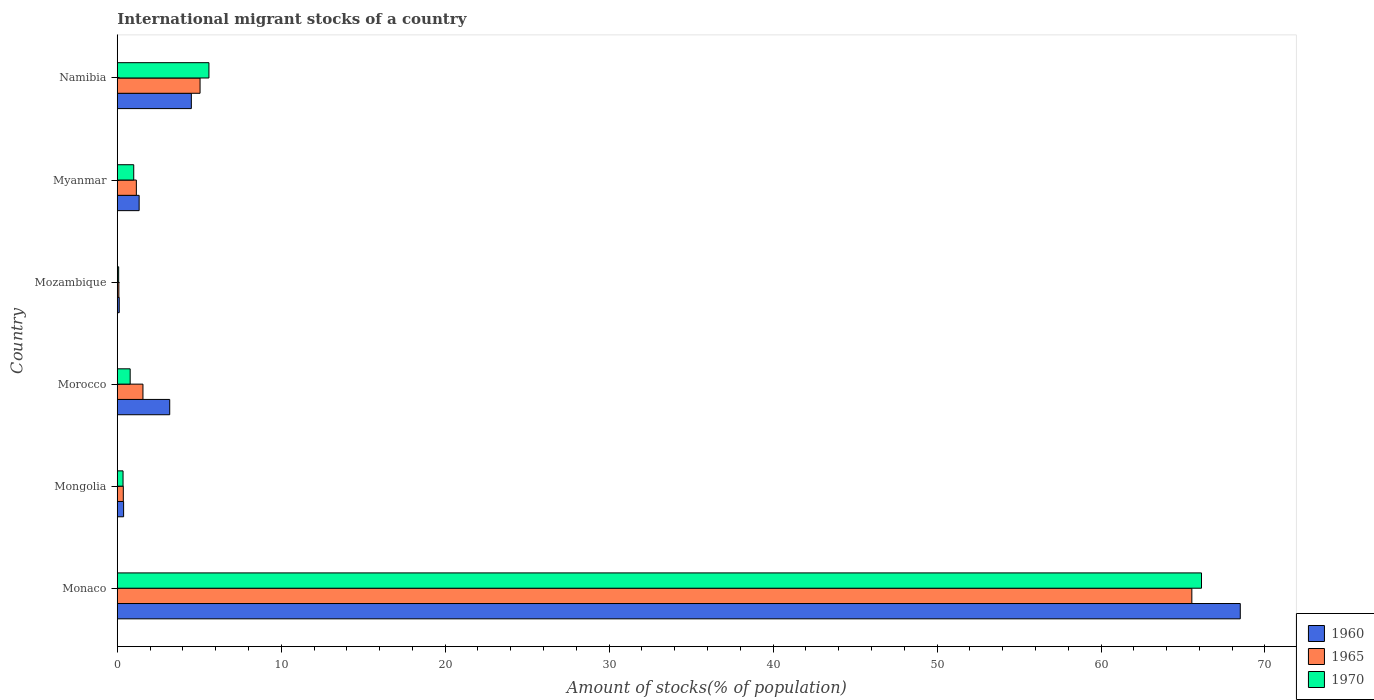How many different coloured bars are there?
Your response must be concise. 3. How many groups of bars are there?
Your answer should be compact. 6. Are the number of bars per tick equal to the number of legend labels?
Offer a terse response. Yes. What is the label of the 3rd group of bars from the top?
Provide a succinct answer. Mozambique. In how many cases, is the number of bars for a given country not equal to the number of legend labels?
Your response must be concise. 0. What is the amount of stocks in in 1960 in Namibia?
Ensure brevity in your answer.  4.52. Across all countries, what is the maximum amount of stocks in in 1960?
Give a very brief answer. 68.5. Across all countries, what is the minimum amount of stocks in in 1960?
Ensure brevity in your answer.  0.12. In which country was the amount of stocks in in 1970 maximum?
Ensure brevity in your answer.  Monaco. In which country was the amount of stocks in in 1965 minimum?
Offer a very short reply. Mozambique. What is the total amount of stocks in in 1960 in the graph?
Make the answer very short. 78.05. What is the difference between the amount of stocks in in 1970 in Mongolia and that in Namibia?
Keep it short and to the point. -5.24. What is the difference between the amount of stocks in in 1965 in Namibia and the amount of stocks in in 1970 in Mozambique?
Keep it short and to the point. 4.96. What is the average amount of stocks in in 1960 per country?
Offer a very short reply. 13.01. What is the difference between the amount of stocks in in 1970 and amount of stocks in in 1960 in Mozambique?
Your response must be concise. -0.04. What is the ratio of the amount of stocks in in 1965 in Mongolia to that in Myanmar?
Your answer should be very brief. 0.32. Is the amount of stocks in in 1960 in Mozambique less than that in Namibia?
Your answer should be very brief. Yes. Is the difference between the amount of stocks in in 1970 in Morocco and Namibia greater than the difference between the amount of stocks in in 1960 in Morocco and Namibia?
Make the answer very short. No. What is the difference between the highest and the second highest amount of stocks in in 1960?
Make the answer very short. 63.98. What is the difference between the highest and the lowest amount of stocks in in 1965?
Your answer should be very brief. 65.44. What does the 2nd bar from the top in Mongolia represents?
Provide a succinct answer. 1965. How many bars are there?
Provide a short and direct response. 18. What is the difference between two consecutive major ticks on the X-axis?
Make the answer very short. 10. Does the graph contain any zero values?
Make the answer very short. No. Does the graph contain grids?
Your response must be concise. No. Where does the legend appear in the graph?
Provide a short and direct response. Bottom right. How are the legend labels stacked?
Offer a very short reply. Vertical. What is the title of the graph?
Give a very brief answer. International migrant stocks of a country. Does "2012" appear as one of the legend labels in the graph?
Keep it short and to the point. No. What is the label or title of the X-axis?
Give a very brief answer. Amount of stocks(% of population). What is the label or title of the Y-axis?
Provide a short and direct response. Country. What is the Amount of stocks(% of population) of 1960 in Monaco?
Offer a very short reply. 68.5. What is the Amount of stocks(% of population) of 1965 in Monaco?
Provide a short and direct response. 65.54. What is the Amount of stocks(% of population) in 1970 in Monaco?
Offer a very short reply. 66.13. What is the Amount of stocks(% of population) of 1960 in Mongolia?
Offer a terse response. 0.39. What is the Amount of stocks(% of population) of 1965 in Mongolia?
Your answer should be compact. 0.37. What is the Amount of stocks(% of population) in 1970 in Mongolia?
Offer a very short reply. 0.35. What is the Amount of stocks(% of population) in 1960 in Morocco?
Ensure brevity in your answer.  3.2. What is the Amount of stocks(% of population) of 1965 in Morocco?
Offer a terse response. 1.57. What is the Amount of stocks(% of population) in 1970 in Morocco?
Keep it short and to the point. 0.79. What is the Amount of stocks(% of population) of 1960 in Mozambique?
Keep it short and to the point. 0.12. What is the Amount of stocks(% of population) of 1965 in Mozambique?
Offer a terse response. 0.1. What is the Amount of stocks(% of population) of 1970 in Mozambique?
Provide a short and direct response. 0.08. What is the Amount of stocks(% of population) of 1960 in Myanmar?
Offer a terse response. 1.33. What is the Amount of stocks(% of population) of 1965 in Myanmar?
Your response must be concise. 1.16. What is the Amount of stocks(% of population) of 1970 in Myanmar?
Keep it short and to the point. 1. What is the Amount of stocks(% of population) in 1960 in Namibia?
Keep it short and to the point. 4.52. What is the Amount of stocks(% of population) of 1965 in Namibia?
Your answer should be very brief. 5.05. What is the Amount of stocks(% of population) of 1970 in Namibia?
Your response must be concise. 5.59. Across all countries, what is the maximum Amount of stocks(% of population) of 1960?
Give a very brief answer. 68.5. Across all countries, what is the maximum Amount of stocks(% of population) in 1965?
Give a very brief answer. 65.54. Across all countries, what is the maximum Amount of stocks(% of population) in 1970?
Provide a short and direct response. 66.13. Across all countries, what is the minimum Amount of stocks(% of population) in 1960?
Your answer should be compact. 0.12. Across all countries, what is the minimum Amount of stocks(% of population) of 1965?
Give a very brief answer. 0.1. Across all countries, what is the minimum Amount of stocks(% of population) in 1970?
Offer a terse response. 0.08. What is the total Amount of stocks(% of population) in 1960 in the graph?
Offer a terse response. 78.05. What is the total Amount of stocks(% of population) in 1965 in the graph?
Provide a succinct answer. 73.78. What is the total Amount of stocks(% of population) in 1970 in the graph?
Provide a short and direct response. 73.95. What is the difference between the Amount of stocks(% of population) in 1960 in Monaco and that in Mongolia?
Keep it short and to the point. 68.11. What is the difference between the Amount of stocks(% of population) of 1965 in Monaco and that in Mongolia?
Provide a short and direct response. 65.17. What is the difference between the Amount of stocks(% of population) in 1970 in Monaco and that in Mongolia?
Keep it short and to the point. 65.78. What is the difference between the Amount of stocks(% of population) of 1960 in Monaco and that in Morocco?
Provide a succinct answer. 65.3. What is the difference between the Amount of stocks(% of population) in 1965 in Monaco and that in Morocco?
Ensure brevity in your answer.  63.98. What is the difference between the Amount of stocks(% of population) of 1970 in Monaco and that in Morocco?
Provide a succinct answer. 65.34. What is the difference between the Amount of stocks(% of population) of 1960 in Monaco and that in Mozambique?
Provide a succinct answer. 68.38. What is the difference between the Amount of stocks(% of population) in 1965 in Monaco and that in Mozambique?
Give a very brief answer. 65.44. What is the difference between the Amount of stocks(% of population) of 1970 in Monaco and that in Mozambique?
Provide a short and direct response. 66.05. What is the difference between the Amount of stocks(% of population) of 1960 in Monaco and that in Myanmar?
Offer a terse response. 67.16. What is the difference between the Amount of stocks(% of population) of 1965 in Monaco and that in Myanmar?
Keep it short and to the point. 64.38. What is the difference between the Amount of stocks(% of population) in 1970 in Monaco and that in Myanmar?
Your response must be concise. 65.13. What is the difference between the Amount of stocks(% of population) of 1960 in Monaco and that in Namibia?
Your answer should be compact. 63.98. What is the difference between the Amount of stocks(% of population) of 1965 in Monaco and that in Namibia?
Give a very brief answer. 60.49. What is the difference between the Amount of stocks(% of population) in 1970 in Monaco and that in Namibia?
Provide a short and direct response. 60.54. What is the difference between the Amount of stocks(% of population) of 1960 in Mongolia and that in Morocco?
Your answer should be very brief. -2.81. What is the difference between the Amount of stocks(% of population) of 1965 in Mongolia and that in Morocco?
Your answer should be compact. -1.2. What is the difference between the Amount of stocks(% of population) in 1970 in Mongolia and that in Morocco?
Your answer should be compact. -0.43. What is the difference between the Amount of stocks(% of population) of 1960 in Mongolia and that in Mozambique?
Your answer should be compact. 0.27. What is the difference between the Amount of stocks(% of population) in 1965 in Mongolia and that in Mozambique?
Your answer should be very brief. 0.27. What is the difference between the Amount of stocks(% of population) of 1970 in Mongolia and that in Mozambique?
Provide a short and direct response. 0.27. What is the difference between the Amount of stocks(% of population) of 1960 in Mongolia and that in Myanmar?
Make the answer very short. -0.95. What is the difference between the Amount of stocks(% of population) in 1965 in Mongolia and that in Myanmar?
Provide a succinct answer. -0.8. What is the difference between the Amount of stocks(% of population) in 1970 in Mongolia and that in Myanmar?
Ensure brevity in your answer.  -0.65. What is the difference between the Amount of stocks(% of population) in 1960 in Mongolia and that in Namibia?
Give a very brief answer. -4.13. What is the difference between the Amount of stocks(% of population) of 1965 in Mongolia and that in Namibia?
Provide a short and direct response. -4.68. What is the difference between the Amount of stocks(% of population) in 1970 in Mongolia and that in Namibia?
Offer a terse response. -5.24. What is the difference between the Amount of stocks(% of population) in 1960 in Morocco and that in Mozambique?
Make the answer very short. 3.08. What is the difference between the Amount of stocks(% of population) of 1965 in Morocco and that in Mozambique?
Offer a very short reply. 1.47. What is the difference between the Amount of stocks(% of population) in 1970 in Morocco and that in Mozambique?
Make the answer very short. 0.7. What is the difference between the Amount of stocks(% of population) in 1960 in Morocco and that in Myanmar?
Your answer should be very brief. 1.86. What is the difference between the Amount of stocks(% of population) in 1965 in Morocco and that in Myanmar?
Your answer should be very brief. 0.4. What is the difference between the Amount of stocks(% of population) of 1970 in Morocco and that in Myanmar?
Your answer should be very brief. -0.22. What is the difference between the Amount of stocks(% of population) in 1960 in Morocco and that in Namibia?
Offer a terse response. -1.32. What is the difference between the Amount of stocks(% of population) in 1965 in Morocco and that in Namibia?
Your answer should be very brief. -3.48. What is the difference between the Amount of stocks(% of population) in 1970 in Morocco and that in Namibia?
Make the answer very short. -4.8. What is the difference between the Amount of stocks(% of population) of 1960 in Mozambique and that in Myanmar?
Keep it short and to the point. -1.21. What is the difference between the Amount of stocks(% of population) in 1965 in Mozambique and that in Myanmar?
Your answer should be very brief. -1.07. What is the difference between the Amount of stocks(% of population) in 1970 in Mozambique and that in Myanmar?
Keep it short and to the point. -0.92. What is the difference between the Amount of stocks(% of population) in 1960 in Mozambique and that in Namibia?
Make the answer very short. -4.4. What is the difference between the Amount of stocks(% of population) of 1965 in Mozambique and that in Namibia?
Your response must be concise. -4.95. What is the difference between the Amount of stocks(% of population) in 1970 in Mozambique and that in Namibia?
Provide a succinct answer. -5.51. What is the difference between the Amount of stocks(% of population) of 1960 in Myanmar and that in Namibia?
Provide a short and direct response. -3.18. What is the difference between the Amount of stocks(% of population) in 1965 in Myanmar and that in Namibia?
Provide a short and direct response. -3.89. What is the difference between the Amount of stocks(% of population) in 1970 in Myanmar and that in Namibia?
Provide a succinct answer. -4.59. What is the difference between the Amount of stocks(% of population) in 1960 in Monaco and the Amount of stocks(% of population) in 1965 in Mongolia?
Keep it short and to the point. 68.13. What is the difference between the Amount of stocks(% of population) of 1960 in Monaco and the Amount of stocks(% of population) of 1970 in Mongolia?
Make the answer very short. 68.14. What is the difference between the Amount of stocks(% of population) of 1965 in Monaco and the Amount of stocks(% of population) of 1970 in Mongolia?
Your answer should be very brief. 65.19. What is the difference between the Amount of stocks(% of population) in 1960 in Monaco and the Amount of stocks(% of population) in 1965 in Morocco?
Your response must be concise. 66.93. What is the difference between the Amount of stocks(% of population) in 1960 in Monaco and the Amount of stocks(% of population) in 1970 in Morocco?
Ensure brevity in your answer.  67.71. What is the difference between the Amount of stocks(% of population) of 1965 in Monaco and the Amount of stocks(% of population) of 1970 in Morocco?
Ensure brevity in your answer.  64.75. What is the difference between the Amount of stocks(% of population) in 1960 in Monaco and the Amount of stocks(% of population) in 1965 in Mozambique?
Keep it short and to the point. 68.4. What is the difference between the Amount of stocks(% of population) of 1960 in Monaco and the Amount of stocks(% of population) of 1970 in Mozambique?
Make the answer very short. 68.41. What is the difference between the Amount of stocks(% of population) in 1965 in Monaco and the Amount of stocks(% of population) in 1970 in Mozambique?
Provide a succinct answer. 65.46. What is the difference between the Amount of stocks(% of population) in 1960 in Monaco and the Amount of stocks(% of population) in 1965 in Myanmar?
Keep it short and to the point. 67.33. What is the difference between the Amount of stocks(% of population) in 1960 in Monaco and the Amount of stocks(% of population) in 1970 in Myanmar?
Your answer should be very brief. 67.49. What is the difference between the Amount of stocks(% of population) of 1965 in Monaco and the Amount of stocks(% of population) of 1970 in Myanmar?
Provide a succinct answer. 64.54. What is the difference between the Amount of stocks(% of population) in 1960 in Monaco and the Amount of stocks(% of population) in 1965 in Namibia?
Your answer should be very brief. 63.45. What is the difference between the Amount of stocks(% of population) in 1960 in Monaco and the Amount of stocks(% of population) in 1970 in Namibia?
Provide a short and direct response. 62.91. What is the difference between the Amount of stocks(% of population) in 1965 in Monaco and the Amount of stocks(% of population) in 1970 in Namibia?
Provide a short and direct response. 59.95. What is the difference between the Amount of stocks(% of population) in 1960 in Mongolia and the Amount of stocks(% of population) in 1965 in Morocco?
Provide a succinct answer. -1.18. What is the difference between the Amount of stocks(% of population) of 1960 in Mongolia and the Amount of stocks(% of population) of 1970 in Morocco?
Keep it short and to the point. -0.4. What is the difference between the Amount of stocks(% of population) of 1965 in Mongolia and the Amount of stocks(% of population) of 1970 in Morocco?
Provide a short and direct response. -0.42. What is the difference between the Amount of stocks(% of population) in 1960 in Mongolia and the Amount of stocks(% of population) in 1965 in Mozambique?
Your answer should be compact. 0.29. What is the difference between the Amount of stocks(% of population) of 1960 in Mongolia and the Amount of stocks(% of population) of 1970 in Mozambique?
Your answer should be compact. 0.3. What is the difference between the Amount of stocks(% of population) in 1965 in Mongolia and the Amount of stocks(% of population) in 1970 in Mozambique?
Give a very brief answer. 0.28. What is the difference between the Amount of stocks(% of population) of 1960 in Mongolia and the Amount of stocks(% of population) of 1965 in Myanmar?
Your answer should be compact. -0.78. What is the difference between the Amount of stocks(% of population) in 1960 in Mongolia and the Amount of stocks(% of population) in 1970 in Myanmar?
Provide a succinct answer. -0.62. What is the difference between the Amount of stocks(% of population) in 1965 in Mongolia and the Amount of stocks(% of population) in 1970 in Myanmar?
Give a very brief answer. -0.64. What is the difference between the Amount of stocks(% of population) in 1960 in Mongolia and the Amount of stocks(% of population) in 1965 in Namibia?
Provide a short and direct response. -4.66. What is the difference between the Amount of stocks(% of population) in 1960 in Mongolia and the Amount of stocks(% of population) in 1970 in Namibia?
Make the answer very short. -5.21. What is the difference between the Amount of stocks(% of population) in 1965 in Mongolia and the Amount of stocks(% of population) in 1970 in Namibia?
Provide a succinct answer. -5.22. What is the difference between the Amount of stocks(% of population) of 1960 in Morocco and the Amount of stocks(% of population) of 1965 in Mozambique?
Ensure brevity in your answer.  3.1. What is the difference between the Amount of stocks(% of population) in 1960 in Morocco and the Amount of stocks(% of population) in 1970 in Mozambique?
Provide a succinct answer. 3.11. What is the difference between the Amount of stocks(% of population) of 1965 in Morocco and the Amount of stocks(% of population) of 1970 in Mozambique?
Ensure brevity in your answer.  1.48. What is the difference between the Amount of stocks(% of population) of 1960 in Morocco and the Amount of stocks(% of population) of 1965 in Myanmar?
Offer a very short reply. 2.04. What is the difference between the Amount of stocks(% of population) in 1960 in Morocco and the Amount of stocks(% of population) in 1970 in Myanmar?
Provide a succinct answer. 2.2. What is the difference between the Amount of stocks(% of population) of 1965 in Morocco and the Amount of stocks(% of population) of 1970 in Myanmar?
Offer a terse response. 0.56. What is the difference between the Amount of stocks(% of population) in 1960 in Morocco and the Amount of stocks(% of population) in 1965 in Namibia?
Offer a terse response. -1.85. What is the difference between the Amount of stocks(% of population) in 1960 in Morocco and the Amount of stocks(% of population) in 1970 in Namibia?
Your response must be concise. -2.39. What is the difference between the Amount of stocks(% of population) in 1965 in Morocco and the Amount of stocks(% of population) in 1970 in Namibia?
Offer a terse response. -4.03. What is the difference between the Amount of stocks(% of population) of 1960 in Mozambique and the Amount of stocks(% of population) of 1965 in Myanmar?
Your answer should be compact. -1.04. What is the difference between the Amount of stocks(% of population) in 1960 in Mozambique and the Amount of stocks(% of population) in 1970 in Myanmar?
Your answer should be compact. -0.88. What is the difference between the Amount of stocks(% of population) of 1965 in Mozambique and the Amount of stocks(% of population) of 1970 in Myanmar?
Offer a terse response. -0.91. What is the difference between the Amount of stocks(% of population) of 1960 in Mozambique and the Amount of stocks(% of population) of 1965 in Namibia?
Provide a succinct answer. -4.93. What is the difference between the Amount of stocks(% of population) in 1960 in Mozambique and the Amount of stocks(% of population) in 1970 in Namibia?
Give a very brief answer. -5.47. What is the difference between the Amount of stocks(% of population) of 1965 in Mozambique and the Amount of stocks(% of population) of 1970 in Namibia?
Offer a very short reply. -5.49. What is the difference between the Amount of stocks(% of population) in 1960 in Myanmar and the Amount of stocks(% of population) in 1965 in Namibia?
Offer a terse response. -3.71. What is the difference between the Amount of stocks(% of population) of 1960 in Myanmar and the Amount of stocks(% of population) of 1970 in Namibia?
Make the answer very short. -4.26. What is the difference between the Amount of stocks(% of population) of 1965 in Myanmar and the Amount of stocks(% of population) of 1970 in Namibia?
Ensure brevity in your answer.  -4.43. What is the average Amount of stocks(% of population) in 1960 per country?
Ensure brevity in your answer.  13.01. What is the average Amount of stocks(% of population) of 1965 per country?
Your response must be concise. 12.3. What is the average Amount of stocks(% of population) of 1970 per country?
Your answer should be very brief. 12.32. What is the difference between the Amount of stocks(% of population) in 1960 and Amount of stocks(% of population) in 1965 in Monaco?
Your response must be concise. 2.95. What is the difference between the Amount of stocks(% of population) in 1960 and Amount of stocks(% of population) in 1970 in Monaco?
Your answer should be compact. 2.37. What is the difference between the Amount of stocks(% of population) in 1965 and Amount of stocks(% of population) in 1970 in Monaco?
Provide a succinct answer. -0.59. What is the difference between the Amount of stocks(% of population) in 1960 and Amount of stocks(% of population) in 1965 in Mongolia?
Keep it short and to the point. 0.02. What is the difference between the Amount of stocks(% of population) of 1960 and Amount of stocks(% of population) of 1970 in Mongolia?
Ensure brevity in your answer.  0.03. What is the difference between the Amount of stocks(% of population) of 1965 and Amount of stocks(% of population) of 1970 in Mongolia?
Your answer should be very brief. 0.02. What is the difference between the Amount of stocks(% of population) of 1960 and Amount of stocks(% of population) of 1965 in Morocco?
Your answer should be compact. 1.63. What is the difference between the Amount of stocks(% of population) of 1960 and Amount of stocks(% of population) of 1970 in Morocco?
Make the answer very short. 2.41. What is the difference between the Amount of stocks(% of population) in 1965 and Amount of stocks(% of population) in 1970 in Morocco?
Offer a very short reply. 0.78. What is the difference between the Amount of stocks(% of population) in 1960 and Amount of stocks(% of population) in 1965 in Mozambique?
Provide a succinct answer. 0.02. What is the difference between the Amount of stocks(% of population) in 1960 and Amount of stocks(% of population) in 1970 in Mozambique?
Give a very brief answer. 0.04. What is the difference between the Amount of stocks(% of population) of 1965 and Amount of stocks(% of population) of 1970 in Mozambique?
Provide a short and direct response. 0.01. What is the difference between the Amount of stocks(% of population) of 1960 and Amount of stocks(% of population) of 1965 in Myanmar?
Your answer should be very brief. 0.17. What is the difference between the Amount of stocks(% of population) of 1960 and Amount of stocks(% of population) of 1970 in Myanmar?
Give a very brief answer. 0.33. What is the difference between the Amount of stocks(% of population) of 1965 and Amount of stocks(% of population) of 1970 in Myanmar?
Offer a very short reply. 0.16. What is the difference between the Amount of stocks(% of population) in 1960 and Amount of stocks(% of population) in 1965 in Namibia?
Your response must be concise. -0.53. What is the difference between the Amount of stocks(% of population) of 1960 and Amount of stocks(% of population) of 1970 in Namibia?
Your response must be concise. -1.07. What is the difference between the Amount of stocks(% of population) of 1965 and Amount of stocks(% of population) of 1970 in Namibia?
Provide a succinct answer. -0.54. What is the ratio of the Amount of stocks(% of population) in 1960 in Monaco to that in Mongolia?
Keep it short and to the point. 177.66. What is the ratio of the Amount of stocks(% of population) of 1965 in Monaco to that in Mongolia?
Make the answer very short. 178.2. What is the ratio of the Amount of stocks(% of population) in 1970 in Monaco to that in Mongolia?
Offer a very short reply. 187.89. What is the ratio of the Amount of stocks(% of population) in 1960 in Monaco to that in Morocco?
Provide a succinct answer. 21.41. What is the ratio of the Amount of stocks(% of population) of 1965 in Monaco to that in Morocco?
Give a very brief answer. 41.87. What is the ratio of the Amount of stocks(% of population) in 1970 in Monaco to that in Morocco?
Your response must be concise. 84.09. What is the ratio of the Amount of stocks(% of population) in 1960 in Monaco to that in Mozambique?
Your response must be concise. 573.53. What is the ratio of the Amount of stocks(% of population) in 1965 in Monaco to that in Mozambique?
Offer a very short reply. 678.35. What is the ratio of the Amount of stocks(% of population) in 1970 in Monaco to that in Mozambique?
Make the answer very short. 786.17. What is the ratio of the Amount of stocks(% of population) of 1960 in Monaco to that in Myanmar?
Offer a very short reply. 51.36. What is the ratio of the Amount of stocks(% of population) in 1965 in Monaco to that in Myanmar?
Make the answer very short. 56.34. What is the ratio of the Amount of stocks(% of population) of 1970 in Monaco to that in Myanmar?
Your answer should be very brief. 65.91. What is the ratio of the Amount of stocks(% of population) in 1960 in Monaco to that in Namibia?
Provide a succinct answer. 15.16. What is the ratio of the Amount of stocks(% of population) in 1965 in Monaco to that in Namibia?
Your answer should be very brief. 12.98. What is the ratio of the Amount of stocks(% of population) in 1970 in Monaco to that in Namibia?
Provide a short and direct response. 11.83. What is the ratio of the Amount of stocks(% of population) in 1960 in Mongolia to that in Morocco?
Make the answer very short. 0.12. What is the ratio of the Amount of stocks(% of population) in 1965 in Mongolia to that in Morocco?
Your answer should be very brief. 0.23. What is the ratio of the Amount of stocks(% of population) of 1970 in Mongolia to that in Morocco?
Your answer should be very brief. 0.45. What is the ratio of the Amount of stocks(% of population) of 1960 in Mongolia to that in Mozambique?
Provide a succinct answer. 3.23. What is the ratio of the Amount of stocks(% of population) in 1965 in Mongolia to that in Mozambique?
Provide a short and direct response. 3.81. What is the ratio of the Amount of stocks(% of population) of 1970 in Mongolia to that in Mozambique?
Provide a short and direct response. 4.18. What is the ratio of the Amount of stocks(% of population) in 1960 in Mongolia to that in Myanmar?
Provide a succinct answer. 0.29. What is the ratio of the Amount of stocks(% of population) in 1965 in Mongolia to that in Myanmar?
Provide a succinct answer. 0.32. What is the ratio of the Amount of stocks(% of population) in 1970 in Mongolia to that in Myanmar?
Provide a short and direct response. 0.35. What is the ratio of the Amount of stocks(% of population) of 1960 in Mongolia to that in Namibia?
Your answer should be very brief. 0.09. What is the ratio of the Amount of stocks(% of population) in 1965 in Mongolia to that in Namibia?
Give a very brief answer. 0.07. What is the ratio of the Amount of stocks(% of population) in 1970 in Mongolia to that in Namibia?
Provide a short and direct response. 0.06. What is the ratio of the Amount of stocks(% of population) of 1960 in Morocco to that in Mozambique?
Ensure brevity in your answer.  26.78. What is the ratio of the Amount of stocks(% of population) of 1965 in Morocco to that in Mozambique?
Offer a terse response. 16.2. What is the ratio of the Amount of stocks(% of population) in 1970 in Morocco to that in Mozambique?
Give a very brief answer. 9.35. What is the ratio of the Amount of stocks(% of population) in 1960 in Morocco to that in Myanmar?
Make the answer very short. 2.4. What is the ratio of the Amount of stocks(% of population) of 1965 in Morocco to that in Myanmar?
Provide a succinct answer. 1.35. What is the ratio of the Amount of stocks(% of population) in 1970 in Morocco to that in Myanmar?
Your answer should be compact. 0.78. What is the ratio of the Amount of stocks(% of population) of 1960 in Morocco to that in Namibia?
Your answer should be compact. 0.71. What is the ratio of the Amount of stocks(% of population) of 1965 in Morocco to that in Namibia?
Make the answer very short. 0.31. What is the ratio of the Amount of stocks(% of population) in 1970 in Morocco to that in Namibia?
Your answer should be very brief. 0.14. What is the ratio of the Amount of stocks(% of population) of 1960 in Mozambique to that in Myanmar?
Offer a terse response. 0.09. What is the ratio of the Amount of stocks(% of population) of 1965 in Mozambique to that in Myanmar?
Keep it short and to the point. 0.08. What is the ratio of the Amount of stocks(% of population) in 1970 in Mozambique to that in Myanmar?
Your answer should be very brief. 0.08. What is the ratio of the Amount of stocks(% of population) in 1960 in Mozambique to that in Namibia?
Provide a short and direct response. 0.03. What is the ratio of the Amount of stocks(% of population) of 1965 in Mozambique to that in Namibia?
Provide a short and direct response. 0.02. What is the ratio of the Amount of stocks(% of population) in 1970 in Mozambique to that in Namibia?
Your response must be concise. 0.01. What is the ratio of the Amount of stocks(% of population) in 1960 in Myanmar to that in Namibia?
Give a very brief answer. 0.3. What is the ratio of the Amount of stocks(% of population) in 1965 in Myanmar to that in Namibia?
Your answer should be very brief. 0.23. What is the ratio of the Amount of stocks(% of population) in 1970 in Myanmar to that in Namibia?
Make the answer very short. 0.18. What is the difference between the highest and the second highest Amount of stocks(% of population) of 1960?
Your answer should be very brief. 63.98. What is the difference between the highest and the second highest Amount of stocks(% of population) in 1965?
Provide a succinct answer. 60.49. What is the difference between the highest and the second highest Amount of stocks(% of population) of 1970?
Provide a succinct answer. 60.54. What is the difference between the highest and the lowest Amount of stocks(% of population) of 1960?
Your response must be concise. 68.38. What is the difference between the highest and the lowest Amount of stocks(% of population) in 1965?
Your answer should be compact. 65.44. What is the difference between the highest and the lowest Amount of stocks(% of population) of 1970?
Keep it short and to the point. 66.05. 